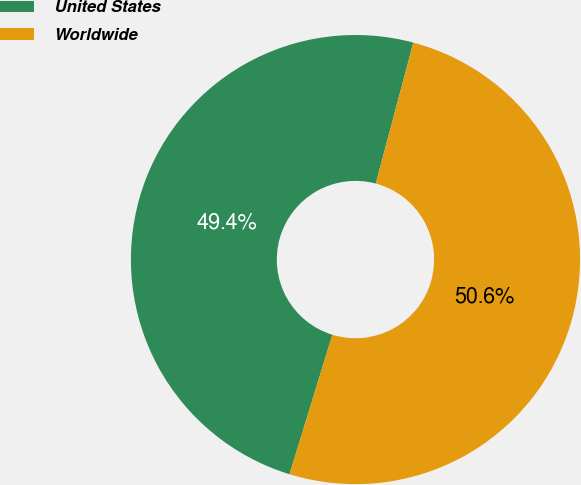Convert chart. <chart><loc_0><loc_0><loc_500><loc_500><pie_chart><fcel>United States<fcel>Worldwide<nl><fcel>49.41%<fcel>50.59%<nl></chart> 